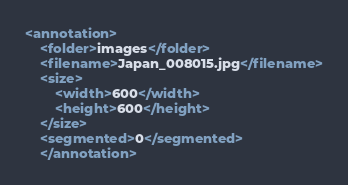<code> <loc_0><loc_0><loc_500><loc_500><_XML_><annotation>
    <folder>images</folder>
    <filename>Japan_008015.jpg</filename>
    <size>
        <width>600</width>
        <height>600</height>
    </size>
    <segmented>0</segmented>
    </annotation></code> 